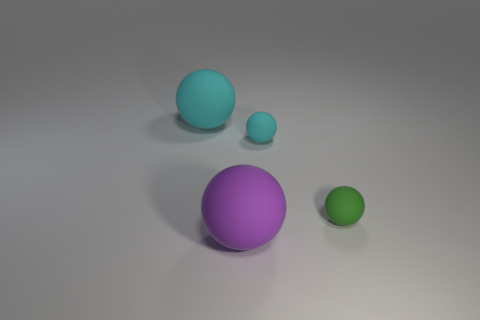There is a large cyan object; is its shape the same as the tiny cyan thing that is to the right of the large purple sphere?
Ensure brevity in your answer.  Yes. Is the shape of the matte object that is behind the tiny cyan thing the same as  the purple rubber thing?
Your answer should be very brief. Yes. What is the size of the purple object?
Make the answer very short. Large. What is the color of the other tiny rubber object that is the same shape as the tiny green matte thing?
Make the answer very short. Cyan. There is a matte ball in front of the green ball; is it the same size as the cyan rubber object to the left of the large purple rubber thing?
Your answer should be compact. Yes. Are there the same number of purple spheres that are on the left side of the purple rubber sphere and big things that are on the right side of the small cyan object?
Your answer should be compact. Yes. There is a purple rubber thing; is it the same size as the cyan matte sphere that is to the left of the tiny cyan matte object?
Ensure brevity in your answer.  Yes. Is there a object on the left side of the big ball left of the big purple sphere?
Keep it short and to the point. No. Are there any large yellow objects that have the same shape as the tiny green object?
Give a very brief answer. No. What number of big purple objects are behind the cyan rubber ball that is to the right of the thing that is in front of the tiny green object?
Your answer should be compact. 0. 